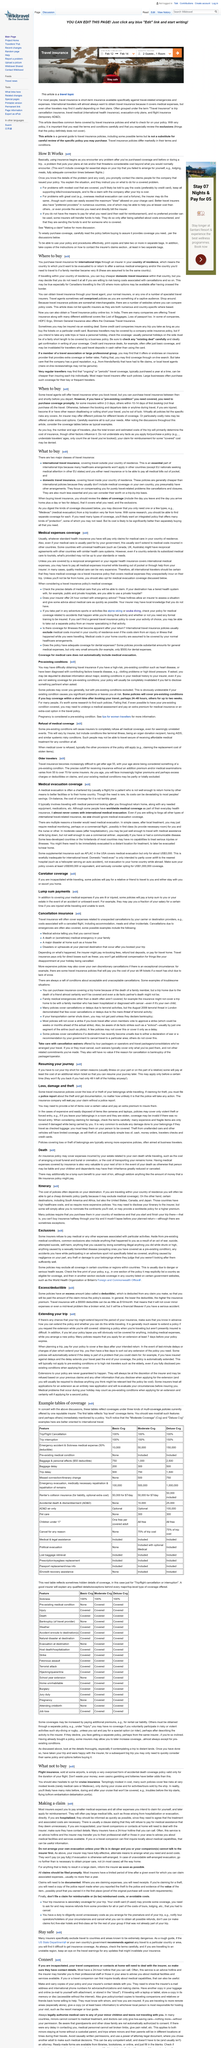Identify some key points in this picture. The requirement for many policies regarding purchasing a policy is that it must be purchased in the policyholder's country of residence and that the policy must be started and finished during the trip in the policyholder's country of residence. If you are hospitalized, it is advisable to inform your insurer as soon as possible, rather than when you are better. If you disclose a pre-existing medical condition, you may still need to undergo a medical assessment. Travel insurance, grouped under the term "Travel Insurance," comprises of trip cancellation insurance, travel medical insurance (international health insurance), evacuation-only plans, and flight insurance (temporary accidental death and dismemberment). The number of travelers is one of the factors that determines the cost of insurance. Yes, it does. 